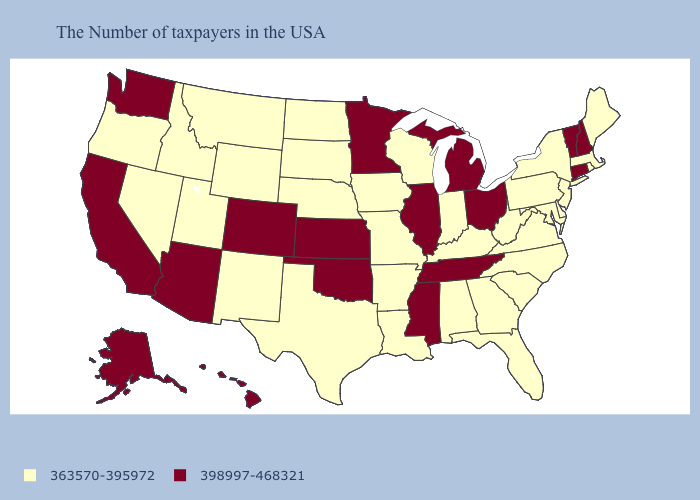What is the highest value in the West ?
Answer briefly. 398997-468321. Does Ohio have a lower value than Arizona?
Be succinct. No. How many symbols are there in the legend?
Give a very brief answer. 2. What is the value of North Dakota?
Give a very brief answer. 363570-395972. Does Idaho have the highest value in the West?
Keep it brief. No. What is the value of Wyoming?
Write a very short answer. 363570-395972. Name the states that have a value in the range 363570-395972?
Keep it brief. Maine, Massachusetts, Rhode Island, New York, New Jersey, Delaware, Maryland, Pennsylvania, Virginia, North Carolina, South Carolina, West Virginia, Florida, Georgia, Kentucky, Indiana, Alabama, Wisconsin, Louisiana, Missouri, Arkansas, Iowa, Nebraska, Texas, South Dakota, North Dakota, Wyoming, New Mexico, Utah, Montana, Idaho, Nevada, Oregon. Name the states that have a value in the range 363570-395972?
Concise answer only. Maine, Massachusetts, Rhode Island, New York, New Jersey, Delaware, Maryland, Pennsylvania, Virginia, North Carolina, South Carolina, West Virginia, Florida, Georgia, Kentucky, Indiana, Alabama, Wisconsin, Louisiana, Missouri, Arkansas, Iowa, Nebraska, Texas, South Dakota, North Dakota, Wyoming, New Mexico, Utah, Montana, Idaho, Nevada, Oregon. Does Rhode Island have the lowest value in the Northeast?
Concise answer only. Yes. Does Colorado have the highest value in the West?
Give a very brief answer. Yes. Does the map have missing data?
Answer briefly. No. How many symbols are there in the legend?
Short answer required. 2. Does Arkansas have the lowest value in the South?
Keep it brief. Yes. 